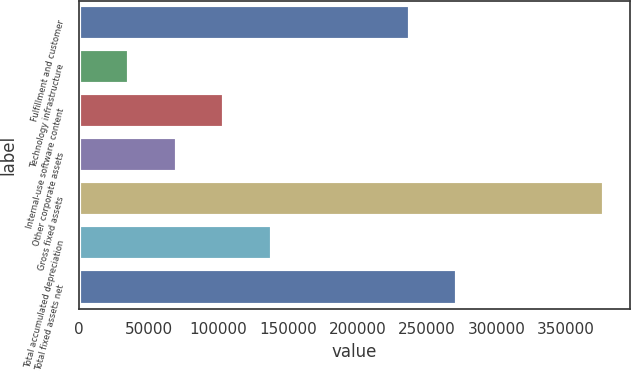Convert chart. <chart><loc_0><loc_0><loc_500><loc_500><bar_chart><fcel>Fulfillment and customer<fcel>Technology infrastructure<fcel>Internal-use software content<fcel>Other corporate assets<fcel>Gross fixed assets<fcel>Total accumulated depreciation<fcel>Total fixed assets net<nl><fcel>237635<fcel>36037<fcel>104228<fcel>70132.7<fcel>376994<fcel>138324<fcel>271731<nl></chart> 